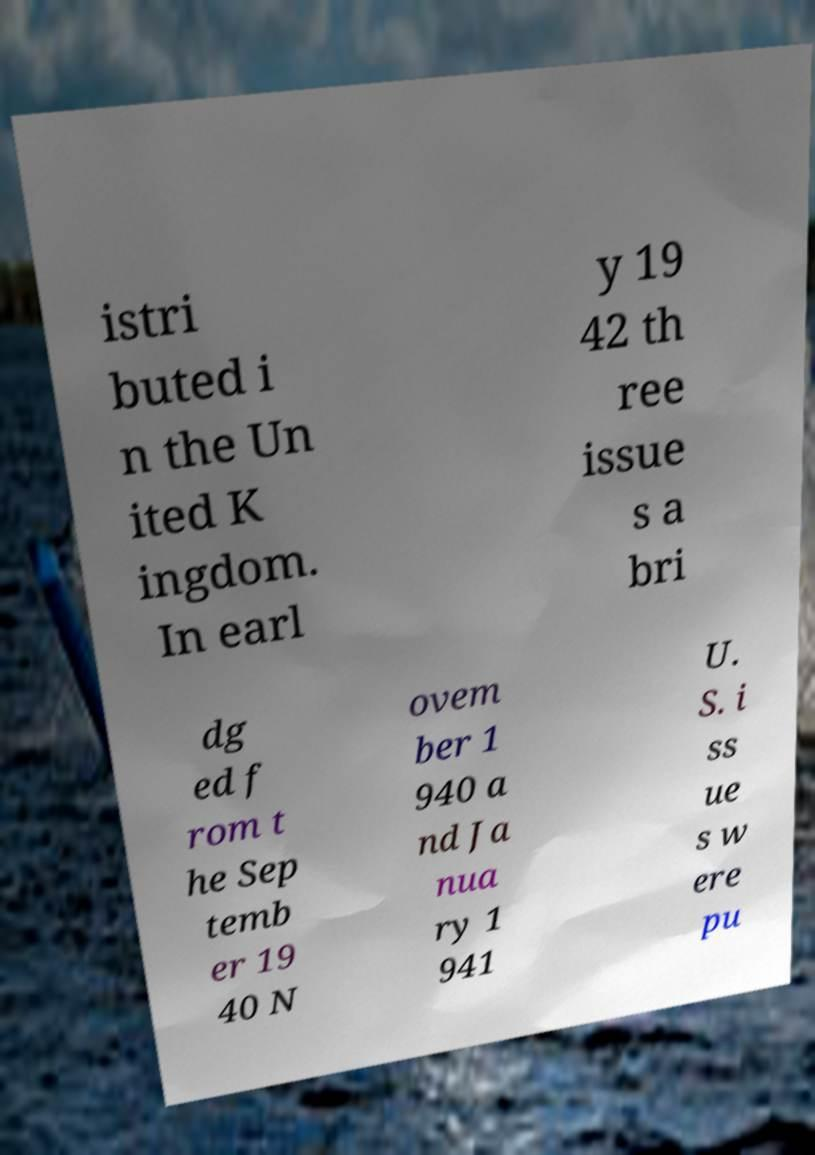I need the written content from this picture converted into text. Can you do that? istri buted i n the Un ited K ingdom. In earl y 19 42 th ree issue s a bri dg ed f rom t he Sep temb er 19 40 N ovem ber 1 940 a nd Ja nua ry 1 941 U. S. i ss ue s w ere pu 